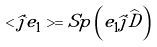<formula> <loc_0><loc_0><loc_500><loc_500>< \widehat { j } e _ { 1 } > = S p \left ( e _ { 1 } \widehat { j } \widehat { D } \right )</formula> 